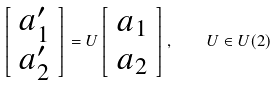<formula> <loc_0><loc_0><loc_500><loc_500>\left [ \begin{array} { c c } a _ { 1 } ^ { \prime } \\ a _ { 2 } ^ { \prime } \end{array} \right ] = U \left [ \begin{array} { c c } a _ { 1 } \\ a _ { 2 } \end{array} \right ] , \quad U \in U ( 2 )</formula> 